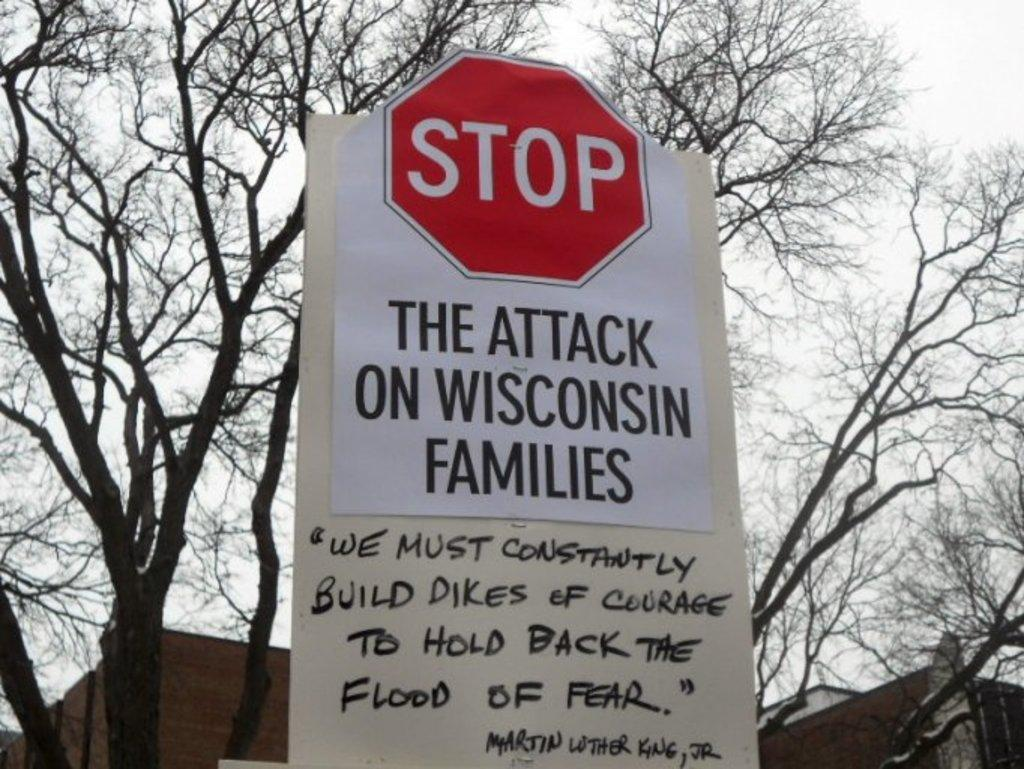What is on the sign board that is visible in the image? There is a sign board with text in the image. What is located behind the sign board? There is a tree behind the sign board. What can be seen in the background of the image? There are buildings and the sky visible in the background of the image. Can you hear the bell ringing in the image? There is no bell present in the image, so it cannot be heard. Is there a spy hiding behind the tree in the image? There is no indication of a spy or any hidden figure in the image. 